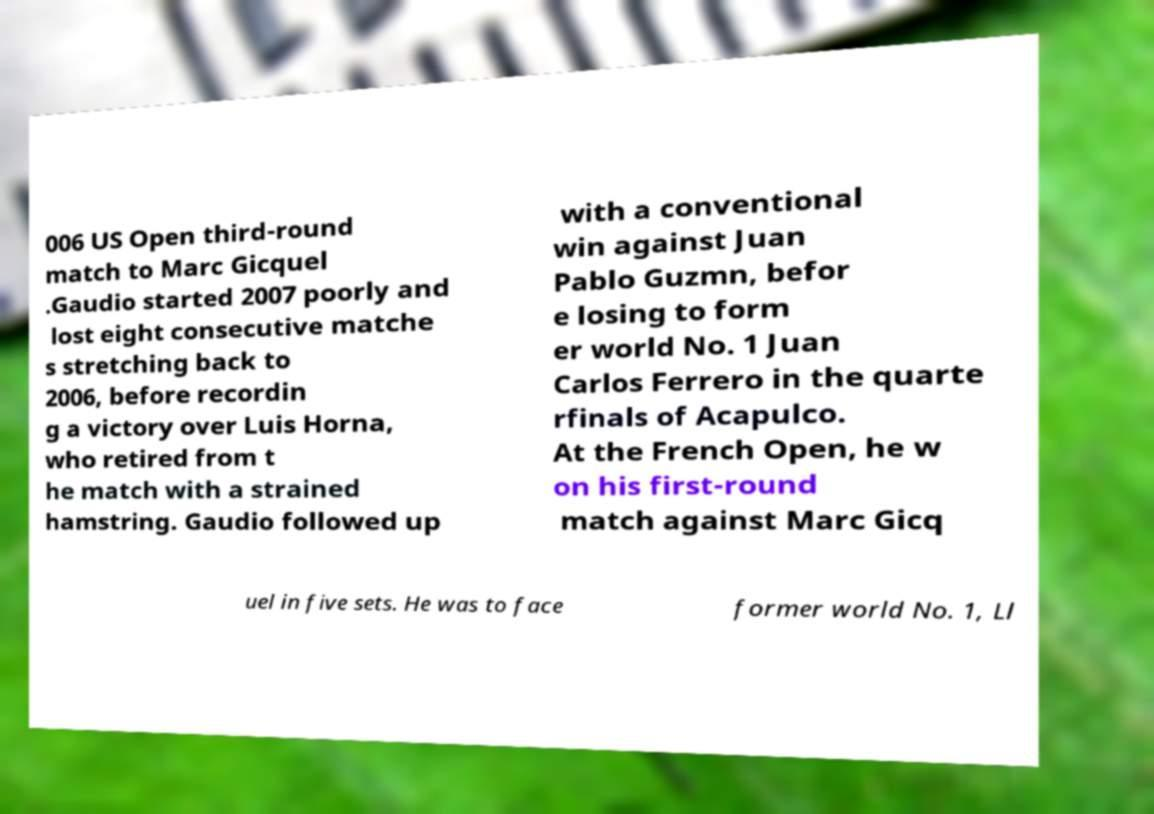Could you extract and type out the text from this image? 006 US Open third-round match to Marc Gicquel .Gaudio started 2007 poorly and lost eight consecutive matche s stretching back to 2006, before recordin g a victory over Luis Horna, who retired from t he match with a strained hamstring. Gaudio followed up with a conventional win against Juan Pablo Guzmn, befor e losing to form er world No. 1 Juan Carlos Ferrero in the quarte rfinals of Acapulco. At the French Open, he w on his first-round match against Marc Gicq uel in five sets. He was to face former world No. 1, Ll 